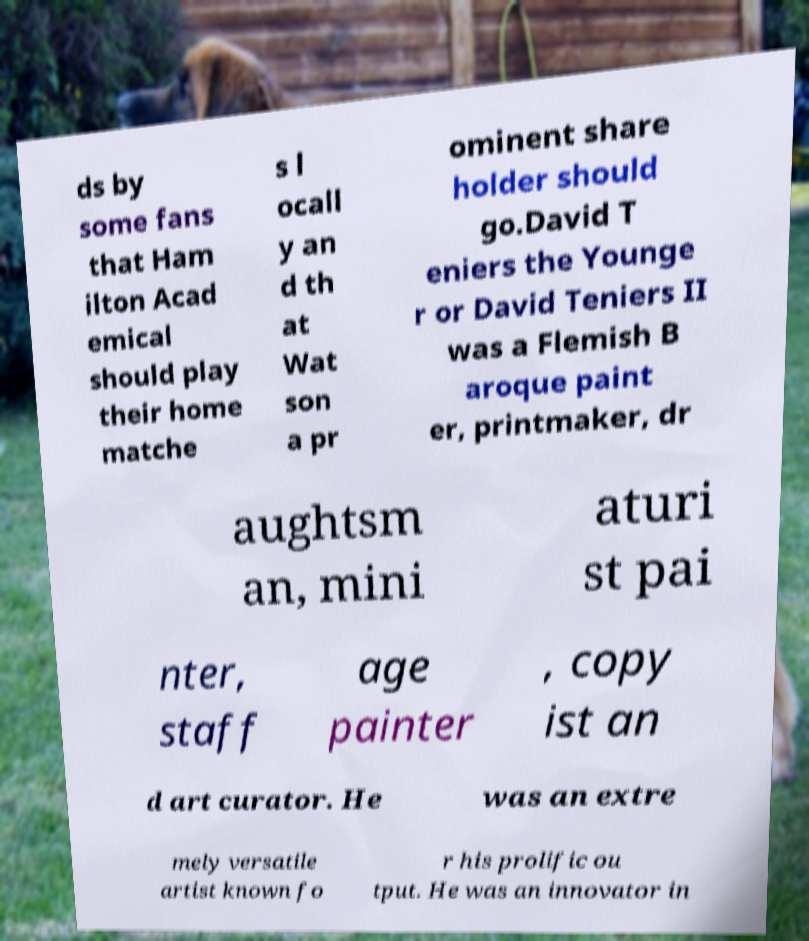Please identify and transcribe the text found in this image. ds by some fans that Ham ilton Acad emical should play their home matche s l ocall y an d th at Wat son a pr ominent share holder should go.David T eniers the Younge r or David Teniers II was a Flemish B aroque paint er, printmaker, dr aughtsm an, mini aturi st pai nter, staff age painter , copy ist an d art curator. He was an extre mely versatile artist known fo r his prolific ou tput. He was an innovator in 